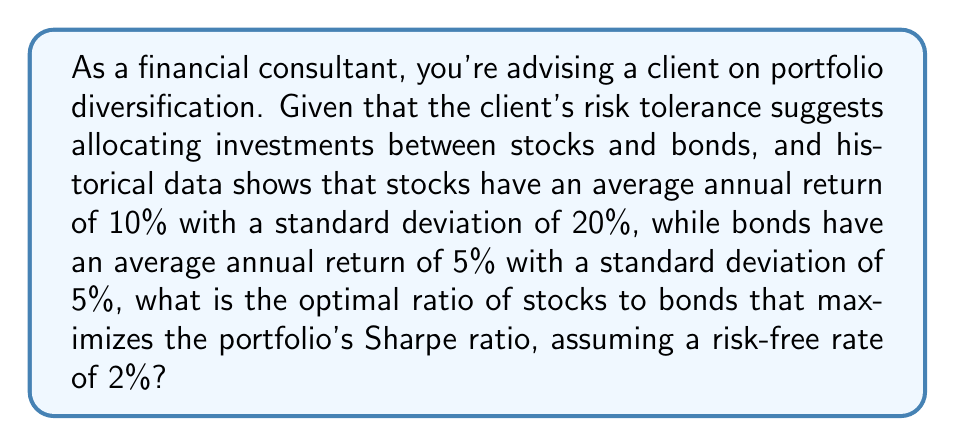Provide a solution to this math problem. To solve this problem, we'll use the concept of the Sharpe ratio and portfolio theory:

1) The Sharpe ratio is defined as:
   $$S = \frac{R_p - R_f}{\sigma_p}$$
   where $R_p$ is the portfolio return, $R_f$ is the risk-free rate, and $\sigma_p$ is the portfolio standard deviation.

2) Let $w$ be the weight of stocks in the portfolio. Then $(1-w)$ is the weight of bonds.

3) The portfolio return is:
   $$R_p = 0.10w + 0.05(1-w) = 0.05 + 0.05w$$

4) The portfolio variance is:
   $$\sigma_p^2 = w^2(0.20)^2 + (1-w)^2(0.05)^2 + 2w(1-w)(0.20)(0.05)(0)$$
   (assuming zero correlation between stocks and bonds for simplicity)

5) Simplifying:
   $$\sigma_p^2 = 0.04w^2 + 0.0025(1-2w+w^2) = 0.0425w^2 - 0.005w + 0.0025$$

6) The portfolio standard deviation is:
   $$\sigma_p = \sqrt{0.0425w^2 - 0.005w + 0.0025}$$

7) Now, we can express the Sharpe ratio as a function of $w$:
   $$S(w) = \frac{0.05 + 0.05w - 0.02}{\sqrt{0.0425w^2 - 0.005w + 0.0025}}$$

8) To maximize this, we differentiate with respect to $w$ and set to zero. This leads to a complex equation.

9) Solving numerically (which would typically be done using software), we find that the maximum occurs at approximately $w = 0.57$.

This means the optimal portfolio consists of about 57% stocks and 43% bonds.
Answer: 57% stocks, 43% bonds 